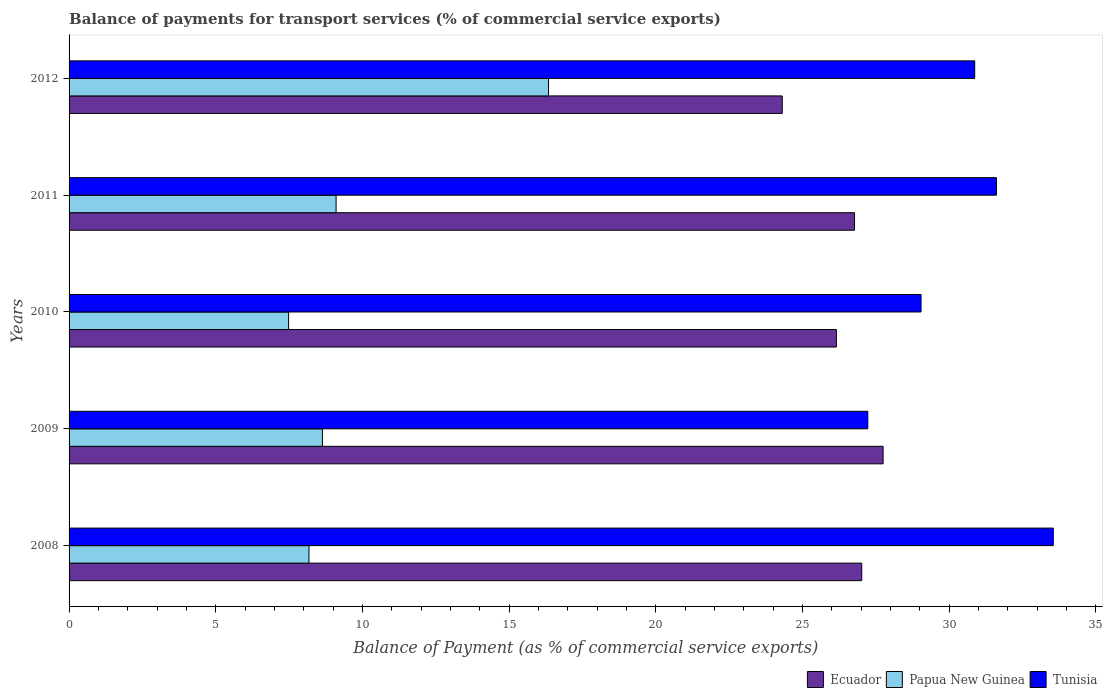Are the number of bars per tick equal to the number of legend labels?
Make the answer very short. Yes. How many bars are there on the 4th tick from the top?
Give a very brief answer. 3. What is the label of the 4th group of bars from the top?
Give a very brief answer. 2009. In how many cases, is the number of bars for a given year not equal to the number of legend labels?
Make the answer very short. 0. What is the balance of payments for transport services in Ecuador in 2008?
Ensure brevity in your answer.  27.02. Across all years, what is the maximum balance of payments for transport services in Ecuador?
Give a very brief answer. 27.75. Across all years, what is the minimum balance of payments for transport services in Papua New Guinea?
Your answer should be compact. 7.48. In which year was the balance of payments for transport services in Ecuador minimum?
Provide a short and direct response. 2012. What is the total balance of payments for transport services in Ecuador in the graph?
Offer a very short reply. 132.02. What is the difference between the balance of payments for transport services in Tunisia in 2008 and that in 2012?
Your response must be concise. 2.68. What is the difference between the balance of payments for transport services in Ecuador in 2011 and the balance of payments for transport services in Tunisia in 2012?
Your answer should be compact. -4.1. What is the average balance of payments for transport services in Tunisia per year?
Provide a short and direct response. 30.46. In the year 2009, what is the difference between the balance of payments for transport services in Tunisia and balance of payments for transport services in Papua New Guinea?
Provide a succinct answer. 18.59. What is the ratio of the balance of payments for transport services in Papua New Guinea in 2009 to that in 2012?
Give a very brief answer. 0.53. Is the balance of payments for transport services in Papua New Guinea in 2009 less than that in 2012?
Your answer should be compact. Yes. What is the difference between the highest and the second highest balance of payments for transport services in Tunisia?
Provide a short and direct response. 1.94. What is the difference between the highest and the lowest balance of payments for transport services in Ecuador?
Give a very brief answer. 3.44. In how many years, is the balance of payments for transport services in Papua New Guinea greater than the average balance of payments for transport services in Papua New Guinea taken over all years?
Your answer should be very brief. 1. What does the 3rd bar from the top in 2012 represents?
Ensure brevity in your answer.  Ecuador. What does the 3rd bar from the bottom in 2011 represents?
Give a very brief answer. Tunisia. Are the values on the major ticks of X-axis written in scientific E-notation?
Provide a short and direct response. No. Does the graph contain any zero values?
Provide a short and direct response. No. Does the graph contain grids?
Your answer should be compact. No. Where does the legend appear in the graph?
Offer a very short reply. Bottom right. How are the legend labels stacked?
Your response must be concise. Horizontal. What is the title of the graph?
Ensure brevity in your answer.  Balance of payments for transport services (% of commercial service exports). What is the label or title of the X-axis?
Ensure brevity in your answer.  Balance of Payment (as % of commercial service exports). What is the label or title of the Y-axis?
Your answer should be very brief. Years. What is the Balance of Payment (as % of commercial service exports) in Ecuador in 2008?
Provide a succinct answer. 27.02. What is the Balance of Payment (as % of commercial service exports) of Papua New Guinea in 2008?
Provide a succinct answer. 8.18. What is the Balance of Payment (as % of commercial service exports) in Tunisia in 2008?
Offer a very short reply. 33.55. What is the Balance of Payment (as % of commercial service exports) in Ecuador in 2009?
Offer a terse response. 27.75. What is the Balance of Payment (as % of commercial service exports) of Papua New Guinea in 2009?
Your answer should be compact. 8.64. What is the Balance of Payment (as % of commercial service exports) in Tunisia in 2009?
Provide a succinct answer. 27.23. What is the Balance of Payment (as % of commercial service exports) in Ecuador in 2010?
Your response must be concise. 26.16. What is the Balance of Payment (as % of commercial service exports) in Papua New Guinea in 2010?
Provide a succinct answer. 7.48. What is the Balance of Payment (as % of commercial service exports) of Tunisia in 2010?
Your answer should be very brief. 29.04. What is the Balance of Payment (as % of commercial service exports) of Ecuador in 2011?
Offer a terse response. 26.78. What is the Balance of Payment (as % of commercial service exports) of Papua New Guinea in 2011?
Make the answer very short. 9.1. What is the Balance of Payment (as % of commercial service exports) in Tunisia in 2011?
Your answer should be compact. 31.61. What is the Balance of Payment (as % of commercial service exports) in Ecuador in 2012?
Give a very brief answer. 24.31. What is the Balance of Payment (as % of commercial service exports) of Papua New Guinea in 2012?
Your answer should be compact. 16.35. What is the Balance of Payment (as % of commercial service exports) of Tunisia in 2012?
Ensure brevity in your answer.  30.87. Across all years, what is the maximum Balance of Payment (as % of commercial service exports) in Ecuador?
Your answer should be compact. 27.75. Across all years, what is the maximum Balance of Payment (as % of commercial service exports) of Papua New Guinea?
Make the answer very short. 16.35. Across all years, what is the maximum Balance of Payment (as % of commercial service exports) of Tunisia?
Offer a terse response. 33.55. Across all years, what is the minimum Balance of Payment (as % of commercial service exports) in Ecuador?
Make the answer very short. 24.31. Across all years, what is the minimum Balance of Payment (as % of commercial service exports) of Papua New Guinea?
Your answer should be very brief. 7.48. Across all years, what is the minimum Balance of Payment (as % of commercial service exports) in Tunisia?
Make the answer very short. 27.23. What is the total Balance of Payment (as % of commercial service exports) of Ecuador in the graph?
Give a very brief answer. 132.02. What is the total Balance of Payment (as % of commercial service exports) in Papua New Guinea in the graph?
Your response must be concise. 49.75. What is the total Balance of Payment (as % of commercial service exports) in Tunisia in the graph?
Provide a short and direct response. 152.31. What is the difference between the Balance of Payment (as % of commercial service exports) in Ecuador in 2008 and that in 2009?
Ensure brevity in your answer.  -0.73. What is the difference between the Balance of Payment (as % of commercial service exports) in Papua New Guinea in 2008 and that in 2009?
Your answer should be very brief. -0.46. What is the difference between the Balance of Payment (as % of commercial service exports) in Tunisia in 2008 and that in 2009?
Keep it short and to the point. 6.32. What is the difference between the Balance of Payment (as % of commercial service exports) of Ecuador in 2008 and that in 2010?
Provide a succinct answer. 0.86. What is the difference between the Balance of Payment (as % of commercial service exports) of Papua New Guinea in 2008 and that in 2010?
Keep it short and to the point. 0.69. What is the difference between the Balance of Payment (as % of commercial service exports) of Tunisia in 2008 and that in 2010?
Your answer should be compact. 4.51. What is the difference between the Balance of Payment (as % of commercial service exports) of Ecuador in 2008 and that in 2011?
Your answer should be compact. 0.25. What is the difference between the Balance of Payment (as % of commercial service exports) in Papua New Guinea in 2008 and that in 2011?
Keep it short and to the point. -0.92. What is the difference between the Balance of Payment (as % of commercial service exports) in Tunisia in 2008 and that in 2011?
Give a very brief answer. 1.94. What is the difference between the Balance of Payment (as % of commercial service exports) of Ecuador in 2008 and that in 2012?
Give a very brief answer. 2.71. What is the difference between the Balance of Payment (as % of commercial service exports) of Papua New Guinea in 2008 and that in 2012?
Offer a terse response. -8.17. What is the difference between the Balance of Payment (as % of commercial service exports) in Tunisia in 2008 and that in 2012?
Offer a very short reply. 2.68. What is the difference between the Balance of Payment (as % of commercial service exports) of Ecuador in 2009 and that in 2010?
Offer a very short reply. 1.59. What is the difference between the Balance of Payment (as % of commercial service exports) in Papua New Guinea in 2009 and that in 2010?
Provide a succinct answer. 1.15. What is the difference between the Balance of Payment (as % of commercial service exports) in Tunisia in 2009 and that in 2010?
Ensure brevity in your answer.  -1.81. What is the difference between the Balance of Payment (as % of commercial service exports) in Ecuador in 2009 and that in 2011?
Provide a succinct answer. 0.98. What is the difference between the Balance of Payment (as % of commercial service exports) of Papua New Guinea in 2009 and that in 2011?
Ensure brevity in your answer.  -0.47. What is the difference between the Balance of Payment (as % of commercial service exports) of Tunisia in 2009 and that in 2011?
Provide a short and direct response. -4.38. What is the difference between the Balance of Payment (as % of commercial service exports) of Ecuador in 2009 and that in 2012?
Make the answer very short. 3.44. What is the difference between the Balance of Payment (as % of commercial service exports) of Papua New Guinea in 2009 and that in 2012?
Your answer should be very brief. -7.71. What is the difference between the Balance of Payment (as % of commercial service exports) of Tunisia in 2009 and that in 2012?
Offer a terse response. -3.64. What is the difference between the Balance of Payment (as % of commercial service exports) in Ecuador in 2010 and that in 2011?
Your answer should be very brief. -0.62. What is the difference between the Balance of Payment (as % of commercial service exports) of Papua New Guinea in 2010 and that in 2011?
Make the answer very short. -1.62. What is the difference between the Balance of Payment (as % of commercial service exports) of Tunisia in 2010 and that in 2011?
Offer a terse response. -2.57. What is the difference between the Balance of Payment (as % of commercial service exports) of Ecuador in 2010 and that in 2012?
Your response must be concise. 1.84. What is the difference between the Balance of Payment (as % of commercial service exports) in Papua New Guinea in 2010 and that in 2012?
Ensure brevity in your answer.  -8.86. What is the difference between the Balance of Payment (as % of commercial service exports) of Tunisia in 2010 and that in 2012?
Offer a very short reply. -1.83. What is the difference between the Balance of Payment (as % of commercial service exports) in Ecuador in 2011 and that in 2012?
Your response must be concise. 2.46. What is the difference between the Balance of Payment (as % of commercial service exports) in Papua New Guinea in 2011 and that in 2012?
Your response must be concise. -7.24. What is the difference between the Balance of Payment (as % of commercial service exports) in Tunisia in 2011 and that in 2012?
Provide a succinct answer. 0.74. What is the difference between the Balance of Payment (as % of commercial service exports) in Ecuador in 2008 and the Balance of Payment (as % of commercial service exports) in Papua New Guinea in 2009?
Your response must be concise. 18.38. What is the difference between the Balance of Payment (as % of commercial service exports) of Ecuador in 2008 and the Balance of Payment (as % of commercial service exports) of Tunisia in 2009?
Keep it short and to the point. -0.21. What is the difference between the Balance of Payment (as % of commercial service exports) of Papua New Guinea in 2008 and the Balance of Payment (as % of commercial service exports) of Tunisia in 2009?
Keep it short and to the point. -19.05. What is the difference between the Balance of Payment (as % of commercial service exports) in Ecuador in 2008 and the Balance of Payment (as % of commercial service exports) in Papua New Guinea in 2010?
Make the answer very short. 19.54. What is the difference between the Balance of Payment (as % of commercial service exports) in Ecuador in 2008 and the Balance of Payment (as % of commercial service exports) in Tunisia in 2010?
Provide a short and direct response. -2.02. What is the difference between the Balance of Payment (as % of commercial service exports) of Papua New Guinea in 2008 and the Balance of Payment (as % of commercial service exports) of Tunisia in 2010?
Your response must be concise. -20.87. What is the difference between the Balance of Payment (as % of commercial service exports) of Ecuador in 2008 and the Balance of Payment (as % of commercial service exports) of Papua New Guinea in 2011?
Make the answer very short. 17.92. What is the difference between the Balance of Payment (as % of commercial service exports) of Ecuador in 2008 and the Balance of Payment (as % of commercial service exports) of Tunisia in 2011?
Ensure brevity in your answer.  -4.59. What is the difference between the Balance of Payment (as % of commercial service exports) of Papua New Guinea in 2008 and the Balance of Payment (as % of commercial service exports) of Tunisia in 2011?
Give a very brief answer. -23.44. What is the difference between the Balance of Payment (as % of commercial service exports) of Ecuador in 2008 and the Balance of Payment (as % of commercial service exports) of Papua New Guinea in 2012?
Your response must be concise. 10.68. What is the difference between the Balance of Payment (as % of commercial service exports) in Ecuador in 2008 and the Balance of Payment (as % of commercial service exports) in Tunisia in 2012?
Your answer should be compact. -3.85. What is the difference between the Balance of Payment (as % of commercial service exports) of Papua New Guinea in 2008 and the Balance of Payment (as % of commercial service exports) of Tunisia in 2012?
Provide a short and direct response. -22.7. What is the difference between the Balance of Payment (as % of commercial service exports) of Ecuador in 2009 and the Balance of Payment (as % of commercial service exports) of Papua New Guinea in 2010?
Provide a short and direct response. 20.27. What is the difference between the Balance of Payment (as % of commercial service exports) in Ecuador in 2009 and the Balance of Payment (as % of commercial service exports) in Tunisia in 2010?
Your response must be concise. -1.29. What is the difference between the Balance of Payment (as % of commercial service exports) of Papua New Guinea in 2009 and the Balance of Payment (as % of commercial service exports) of Tunisia in 2010?
Provide a succinct answer. -20.41. What is the difference between the Balance of Payment (as % of commercial service exports) in Ecuador in 2009 and the Balance of Payment (as % of commercial service exports) in Papua New Guinea in 2011?
Provide a succinct answer. 18.65. What is the difference between the Balance of Payment (as % of commercial service exports) of Ecuador in 2009 and the Balance of Payment (as % of commercial service exports) of Tunisia in 2011?
Provide a succinct answer. -3.86. What is the difference between the Balance of Payment (as % of commercial service exports) of Papua New Guinea in 2009 and the Balance of Payment (as % of commercial service exports) of Tunisia in 2011?
Make the answer very short. -22.98. What is the difference between the Balance of Payment (as % of commercial service exports) in Ecuador in 2009 and the Balance of Payment (as % of commercial service exports) in Papua New Guinea in 2012?
Your answer should be compact. 11.41. What is the difference between the Balance of Payment (as % of commercial service exports) in Ecuador in 2009 and the Balance of Payment (as % of commercial service exports) in Tunisia in 2012?
Your answer should be very brief. -3.12. What is the difference between the Balance of Payment (as % of commercial service exports) of Papua New Guinea in 2009 and the Balance of Payment (as % of commercial service exports) of Tunisia in 2012?
Keep it short and to the point. -22.24. What is the difference between the Balance of Payment (as % of commercial service exports) in Ecuador in 2010 and the Balance of Payment (as % of commercial service exports) in Papua New Guinea in 2011?
Give a very brief answer. 17.05. What is the difference between the Balance of Payment (as % of commercial service exports) of Ecuador in 2010 and the Balance of Payment (as % of commercial service exports) of Tunisia in 2011?
Your answer should be compact. -5.46. What is the difference between the Balance of Payment (as % of commercial service exports) of Papua New Guinea in 2010 and the Balance of Payment (as % of commercial service exports) of Tunisia in 2011?
Provide a short and direct response. -24.13. What is the difference between the Balance of Payment (as % of commercial service exports) in Ecuador in 2010 and the Balance of Payment (as % of commercial service exports) in Papua New Guinea in 2012?
Keep it short and to the point. 9.81. What is the difference between the Balance of Payment (as % of commercial service exports) in Ecuador in 2010 and the Balance of Payment (as % of commercial service exports) in Tunisia in 2012?
Keep it short and to the point. -4.72. What is the difference between the Balance of Payment (as % of commercial service exports) in Papua New Guinea in 2010 and the Balance of Payment (as % of commercial service exports) in Tunisia in 2012?
Give a very brief answer. -23.39. What is the difference between the Balance of Payment (as % of commercial service exports) in Ecuador in 2011 and the Balance of Payment (as % of commercial service exports) in Papua New Guinea in 2012?
Give a very brief answer. 10.43. What is the difference between the Balance of Payment (as % of commercial service exports) in Ecuador in 2011 and the Balance of Payment (as % of commercial service exports) in Tunisia in 2012?
Give a very brief answer. -4.1. What is the difference between the Balance of Payment (as % of commercial service exports) in Papua New Guinea in 2011 and the Balance of Payment (as % of commercial service exports) in Tunisia in 2012?
Make the answer very short. -21.77. What is the average Balance of Payment (as % of commercial service exports) of Ecuador per year?
Keep it short and to the point. 26.4. What is the average Balance of Payment (as % of commercial service exports) of Papua New Guinea per year?
Make the answer very short. 9.95. What is the average Balance of Payment (as % of commercial service exports) in Tunisia per year?
Your answer should be very brief. 30.46. In the year 2008, what is the difference between the Balance of Payment (as % of commercial service exports) of Ecuador and Balance of Payment (as % of commercial service exports) of Papua New Guinea?
Offer a very short reply. 18.84. In the year 2008, what is the difference between the Balance of Payment (as % of commercial service exports) in Ecuador and Balance of Payment (as % of commercial service exports) in Tunisia?
Your answer should be compact. -6.53. In the year 2008, what is the difference between the Balance of Payment (as % of commercial service exports) of Papua New Guinea and Balance of Payment (as % of commercial service exports) of Tunisia?
Give a very brief answer. -25.37. In the year 2009, what is the difference between the Balance of Payment (as % of commercial service exports) of Ecuador and Balance of Payment (as % of commercial service exports) of Papua New Guinea?
Your answer should be very brief. 19.11. In the year 2009, what is the difference between the Balance of Payment (as % of commercial service exports) in Ecuador and Balance of Payment (as % of commercial service exports) in Tunisia?
Your answer should be compact. 0.52. In the year 2009, what is the difference between the Balance of Payment (as % of commercial service exports) of Papua New Guinea and Balance of Payment (as % of commercial service exports) of Tunisia?
Provide a succinct answer. -18.59. In the year 2010, what is the difference between the Balance of Payment (as % of commercial service exports) in Ecuador and Balance of Payment (as % of commercial service exports) in Papua New Guinea?
Provide a short and direct response. 18.67. In the year 2010, what is the difference between the Balance of Payment (as % of commercial service exports) in Ecuador and Balance of Payment (as % of commercial service exports) in Tunisia?
Provide a succinct answer. -2.89. In the year 2010, what is the difference between the Balance of Payment (as % of commercial service exports) of Papua New Guinea and Balance of Payment (as % of commercial service exports) of Tunisia?
Offer a very short reply. -21.56. In the year 2011, what is the difference between the Balance of Payment (as % of commercial service exports) in Ecuador and Balance of Payment (as % of commercial service exports) in Papua New Guinea?
Provide a short and direct response. 17.67. In the year 2011, what is the difference between the Balance of Payment (as % of commercial service exports) in Ecuador and Balance of Payment (as % of commercial service exports) in Tunisia?
Your answer should be compact. -4.84. In the year 2011, what is the difference between the Balance of Payment (as % of commercial service exports) of Papua New Guinea and Balance of Payment (as % of commercial service exports) of Tunisia?
Offer a very short reply. -22.51. In the year 2012, what is the difference between the Balance of Payment (as % of commercial service exports) in Ecuador and Balance of Payment (as % of commercial service exports) in Papua New Guinea?
Offer a terse response. 7.97. In the year 2012, what is the difference between the Balance of Payment (as % of commercial service exports) in Ecuador and Balance of Payment (as % of commercial service exports) in Tunisia?
Your response must be concise. -6.56. In the year 2012, what is the difference between the Balance of Payment (as % of commercial service exports) in Papua New Guinea and Balance of Payment (as % of commercial service exports) in Tunisia?
Offer a terse response. -14.53. What is the ratio of the Balance of Payment (as % of commercial service exports) in Ecuador in 2008 to that in 2009?
Ensure brevity in your answer.  0.97. What is the ratio of the Balance of Payment (as % of commercial service exports) in Papua New Guinea in 2008 to that in 2009?
Your answer should be compact. 0.95. What is the ratio of the Balance of Payment (as % of commercial service exports) of Tunisia in 2008 to that in 2009?
Your answer should be compact. 1.23. What is the ratio of the Balance of Payment (as % of commercial service exports) in Ecuador in 2008 to that in 2010?
Offer a terse response. 1.03. What is the ratio of the Balance of Payment (as % of commercial service exports) of Papua New Guinea in 2008 to that in 2010?
Offer a terse response. 1.09. What is the ratio of the Balance of Payment (as % of commercial service exports) of Tunisia in 2008 to that in 2010?
Offer a very short reply. 1.16. What is the ratio of the Balance of Payment (as % of commercial service exports) of Ecuador in 2008 to that in 2011?
Offer a terse response. 1.01. What is the ratio of the Balance of Payment (as % of commercial service exports) in Papua New Guinea in 2008 to that in 2011?
Provide a short and direct response. 0.9. What is the ratio of the Balance of Payment (as % of commercial service exports) in Tunisia in 2008 to that in 2011?
Your answer should be very brief. 1.06. What is the ratio of the Balance of Payment (as % of commercial service exports) of Ecuador in 2008 to that in 2012?
Ensure brevity in your answer.  1.11. What is the ratio of the Balance of Payment (as % of commercial service exports) of Papua New Guinea in 2008 to that in 2012?
Give a very brief answer. 0.5. What is the ratio of the Balance of Payment (as % of commercial service exports) of Tunisia in 2008 to that in 2012?
Your response must be concise. 1.09. What is the ratio of the Balance of Payment (as % of commercial service exports) of Ecuador in 2009 to that in 2010?
Provide a short and direct response. 1.06. What is the ratio of the Balance of Payment (as % of commercial service exports) in Papua New Guinea in 2009 to that in 2010?
Offer a very short reply. 1.15. What is the ratio of the Balance of Payment (as % of commercial service exports) in Tunisia in 2009 to that in 2010?
Provide a short and direct response. 0.94. What is the ratio of the Balance of Payment (as % of commercial service exports) in Ecuador in 2009 to that in 2011?
Your response must be concise. 1.04. What is the ratio of the Balance of Payment (as % of commercial service exports) in Papua New Guinea in 2009 to that in 2011?
Make the answer very short. 0.95. What is the ratio of the Balance of Payment (as % of commercial service exports) of Tunisia in 2009 to that in 2011?
Offer a terse response. 0.86. What is the ratio of the Balance of Payment (as % of commercial service exports) of Ecuador in 2009 to that in 2012?
Your response must be concise. 1.14. What is the ratio of the Balance of Payment (as % of commercial service exports) in Papua New Guinea in 2009 to that in 2012?
Make the answer very short. 0.53. What is the ratio of the Balance of Payment (as % of commercial service exports) in Tunisia in 2009 to that in 2012?
Ensure brevity in your answer.  0.88. What is the ratio of the Balance of Payment (as % of commercial service exports) of Ecuador in 2010 to that in 2011?
Ensure brevity in your answer.  0.98. What is the ratio of the Balance of Payment (as % of commercial service exports) of Papua New Guinea in 2010 to that in 2011?
Your response must be concise. 0.82. What is the ratio of the Balance of Payment (as % of commercial service exports) of Tunisia in 2010 to that in 2011?
Keep it short and to the point. 0.92. What is the ratio of the Balance of Payment (as % of commercial service exports) in Ecuador in 2010 to that in 2012?
Provide a succinct answer. 1.08. What is the ratio of the Balance of Payment (as % of commercial service exports) in Papua New Guinea in 2010 to that in 2012?
Provide a short and direct response. 0.46. What is the ratio of the Balance of Payment (as % of commercial service exports) in Tunisia in 2010 to that in 2012?
Provide a short and direct response. 0.94. What is the ratio of the Balance of Payment (as % of commercial service exports) in Ecuador in 2011 to that in 2012?
Keep it short and to the point. 1.1. What is the ratio of the Balance of Payment (as % of commercial service exports) of Papua New Guinea in 2011 to that in 2012?
Ensure brevity in your answer.  0.56. What is the ratio of the Balance of Payment (as % of commercial service exports) in Tunisia in 2011 to that in 2012?
Offer a terse response. 1.02. What is the difference between the highest and the second highest Balance of Payment (as % of commercial service exports) in Ecuador?
Give a very brief answer. 0.73. What is the difference between the highest and the second highest Balance of Payment (as % of commercial service exports) of Papua New Guinea?
Ensure brevity in your answer.  7.24. What is the difference between the highest and the second highest Balance of Payment (as % of commercial service exports) in Tunisia?
Provide a succinct answer. 1.94. What is the difference between the highest and the lowest Balance of Payment (as % of commercial service exports) in Ecuador?
Your answer should be very brief. 3.44. What is the difference between the highest and the lowest Balance of Payment (as % of commercial service exports) of Papua New Guinea?
Provide a short and direct response. 8.86. What is the difference between the highest and the lowest Balance of Payment (as % of commercial service exports) of Tunisia?
Offer a very short reply. 6.32. 